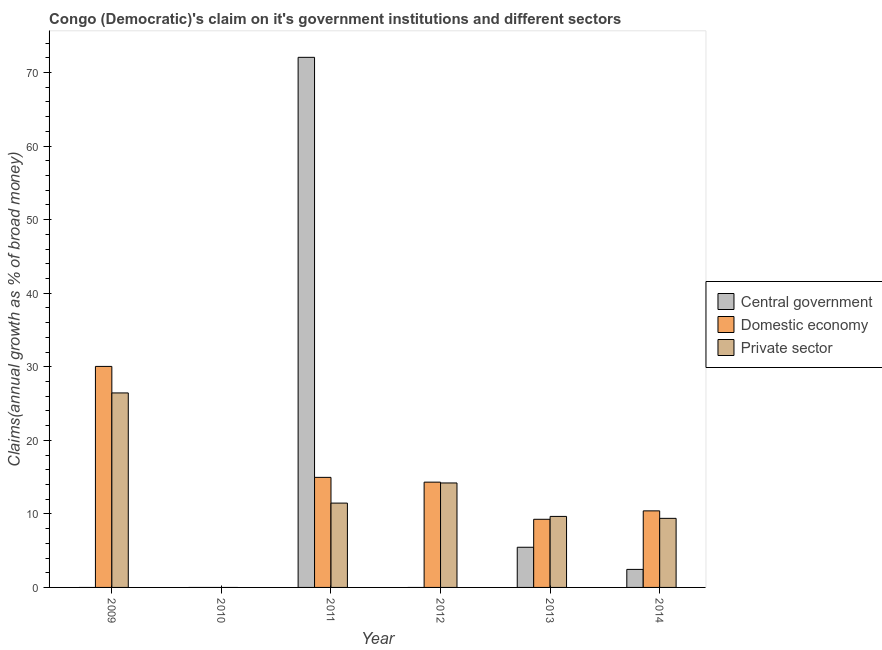How many different coloured bars are there?
Provide a succinct answer. 3. Are the number of bars per tick equal to the number of legend labels?
Offer a very short reply. No. How many bars are there on the 6th tick from the right?
Provide a succinct answer. 2. In how many cases, is the number of bars for a given year not equal to the number of legend labels?
Your response must be concise. 3. What is the percentage of claim on the private sector in 2013?
Ensure brevity in your answer.  9.65. Across all years, what is the maximum percentage of claim on the private sector?
Your response must be concise. 26.44. What is the total percentage of claim on the private sector in the graph?
Offer a very short reply. 71.15. What is the difference between the percentage of claim on the domestic economy in 2013 and that in 2014?
Ensure brevity in your answer.  -1.14. What is the difference between the percentage of claim on the private sector in 2014 and the percentage of claim on the domestic economy in 2012?
Provide a succinct answer. -4.81. What is the average percentage of claim on the domestic economy per year?
Provide a short and direct response. 13.17. In the year 2014, what is the difference between the percentage of claim on the central government and percentage of claim on the domestic economy?
Provide a succinct answer. 0. What is the ratio of the percentage of claim on the domestic economy in 2009 to that in 2012?
Ensure brevity in your answer.  2.1. What is the difference between the highest and the second highest percentage of claim on the domestic economy?
Keep it short and to the point. 15.08. What is the difference between the highest and the lowest percentage of claim on the domestic economy?
Your response must be concise. 30.05. In how many years, is the percentage of claim on the domestic economy greater than the average percentage of claim on the domestic economy taken over all years?
Your response must be concise. 3. Is it the case that in every year, the sum of the percentage of claim on the central government and percentage of claim on the domestic economy is greater than the percentage of claim on the private sector?
Give a very brief answer. No. How many bars are there?
Your response must be concise. 13. Are all the bars in the graph horizontal?
Ensure brevity in your answer.  No. How many years are there in the graph?
Provide a succinct answer. 6. What is the difference between two consecutive major ticks on the Y-axis?
Ensure brevity in your answer.  10. Are the values on the major ticks of Y-axis written in scientific E-notation?
Offer a very short reply. No. Does the graph contain grids?
Ensure brevity in your answer.  No. Where does the legend appear in the graph?
Your answer should be compact. Center right. How many legend labels are there?
Ensure brevity in your answer.  3. How are the legend labels stacked?
Your answer should be very brief. Vertical. What is the title of the graph?
Provide a short and direct response. Congo (Democratic)'s claim on it's government institutions and different sectors. Does "Ages 0-14" appear as one of the legend labels in the graph?
Ensure brevity in your answer.  No. What is the label or title of the X-axis?
Your response must be concise. Year. What is the label or title of the Y-axis?
Offer a very short reply. Claims(annual growth as % of broad money). What is the Claims(annual growth as % of broad money) in Domestic economy in 2009?
Provide a succinct answer. 30.05. What is the Claims(annual growth as % of broad money) of Private sector in 2009?
Your answer should be very brief. 26.44. What is the Claims(annual growth as % of broad money) of Private sector in 2010?
Offer a very short reply. 0. What is the Claims(annual growth as % of broad money) in Central government in 2011?
Offer a very short reply. 72.07. What is the Claims(annual growth as % of broad money) in Domestic economy in 2011?
Your answer should be compact. 14.96. What is the Claims(annual growth as % of broad money) of Private sector in 2011?
Keep it short and to the point. 11.46. What is the Claims(annual growth as % of broad money) of Central government in 2012?
Your answer should be compact. 0. What is the Claims(annual growth as % of broad money) of Domestic economy in 2012?
Your answer should be very brief. 14.31. What is the Claims(annual growth as % of broad money) in Private sector in 2012?
Provide a succinct answer. 14.2. What is the Claims(annual growth as % of broad money) in Central government in 2013?
Give a very brief answer. 5.46. What is the Claims(annual growth as % of broad money) of Domestic economy in 2013?
Offer a terse response. 9.26. What is the Claims(annual growth as % of broad money) of Private sector in 2013?
Make the answer very short. 9.65. What is the Claims(annual growth as % of broad money) in Central government in 2014?
Ensure brevity in your answer.  2.45. What is the Claims(annual growth as % of broad money) of Domestic economy in 2014?
Your response must be concise. 10.41. What is the Claims(annual growth as % of broad money) in Private sector in 2014?
Keep it short and to the point. 9.39. Across all years, what is the maximum Claims(annual growth as % of broad money) of Central government?
Make the answer very short. 72.07. Across all years, what is the maximum Claims(annual growth as % of broad money) of Domestic economy?
Give a very brief answer. 30.05. Across all years, what is the maximum Claims(annual growth as % of broad money) of Private sector?
Your answer should be compact. 26.44. Across all years, what is the minimum Claims(annual growth as % of broad money) in Central government?
Ensure brevity in your answer.  0. Across all years, what is the minimum Claims(annual growth as % of broad money) of Domestic economy?
Your answer should be compact. 0. Across all years, what is the minimum Claims(annual growth as % of broad money) of Private sector?
Provide a short and direct response. 0. What is the total Claims(annual growth as % of broad money) in Central government in the graph?
Provide a short and direct response. 79.98. What is the total Claims(annual growth as % of broad money) of Domestic economy in the graph?
Make the answer very short. 79. What is the total Claims(annual growth as % of broad money) in Private sector in the graph?
Your answer should be very brief. 71.15. What is the difference between the Claims(annual growth as % of broad money) in Domestic economy in 2009 and that in 2011?
Make the answer very short. 15.08. What is the difference between the Claims(annual growth as % of broad money) in Private sector in 2009 and that in 2011?
Offer a very short reply. 14.98. What is the difference between the Claims(annual growth as % of broad money) of Domestic economy in 2009 and that in 2012?
Make the answer very short. 15.73. What is the difference between the Claims(annual growth as % of broad money) in Private sector in 2009 and that in 2012?
Offer a terse response. 12.24. What is the difference between the Claims(annual growth as % of broad money) of Domestic economy in 2009 and that in 2013?
Provide a short and direct response. 20.78. What is the difference between the Claims(annual growth as % of broad money) in Private sector in 2009 and that in 2013?
Give a very brief answer. 16.79. What is the difference between the Claims(annual growth as % of broad money) of Domestic economy in 2009 and that in 2014?
Make the answer very short. 19.64. What is the difference between the Claims(annual growth as % of broad money) in Private sector in 2009 and that in 2014?
Keep it short and to the point. 17.05. What is the difference between the Claims(annual growth as % of broad money) in Domestic economy in 2011 and that in 2012?
Give a very brief answer. 0.65. What is the difference between the Claims(annual growth as % of broad money) of Private sector in 2011 and that in 2012?
Offer a very short reply. -2.74. What is the difference between the Claims(annual growth as % of broad money) of Central government in 2011 and that in 2013?
Offer a terse response. 66.61. What is the difference between the Claims(annual growth as % of broad money) in Domestic economy in 2011 and that in 2013?
Your answer should be very brief. 5.7. What is the difference between the Claims(annual growth as % of broad money) in Private sector in 2011 and that in 2013?
Keep it short and to the point. 1.81. What is the difference between the Claims(annual growth as % of broad money) of Central government in 2011 and that in 2014?
Your answer should be very brief. 69.62. What is the difference between the Claims(annual growth as % of broad money) of Domestic economy in 2011 and that in 2014?
Your answer should be compact. 4.56. What is the difference between the Claims(annual growth as % of broad money) of Private sector in 2011 and that in 2014?
Your answer should be very brief. 2.07. What is the difference between the Claims(annual growth as % of broad money) in Domestic economy in 2012 and that in 2013?
Your answer should be compact. 5.05. What is the difference between the Claims(annual growth as % of broad money) in Private sector in 2012 and that in 2013?
Your answer should be compact. 4.55. What is the difference between the Claims(annual growth as % of broad money) in Domestic economy in 2012 and that in 2014?
Your response must be concise. 3.91. What is the difference between the Claims(annual growth as % of broad money) in Private sector in 2012 and that in 2014?
Your answer should be compact. 4.81. What is the difference between the Claims(annual growth as % of broad money) in Central government in 2013 and that in 2014?
Your response must be concise. 3.01. What is the difference between the Claims(annual growth as % of broad money) in Domestic economy in 2013 and that in 2014?
Your response must be concise. -1.14. What is the difference between the Claims(annual growth as % of broad money) in Private sector in 2013 and that in 2014?
Ensure brevity in your answer.  0.26. What is the difference between the Claims(annual growth as % of broad money) of Domestic economy in 2009 and the Claims(annual growth as % of broad money) of Private sector in 2011?
Give a very brief answer. 18.58. What is the difference between the Claims(annual growth as % of broad money) of Domestic economy in 2009 and the Claims(annual growth as % of broad money) of Private sector in 2012?
Provide a short and direct response. 15.85. What is the difference between the Claims(annual growth as % of broad money) in Domestic economy in 2009 and the Claims(annual growth as % of broad money) in Private sector in 2013?
Provide a short and direct response. 20.39. What is the difference between the Claims(annual growth as % of broad money) in Domestic economy in 2009 and the Claims(annual growth as % of broad money) in Private sector in 2014?
Your response must be concise. 20.66. What is the difference between the Claims(annual growth as % of broad money) of Central government in 2011 and the Claims(annual growth as % of broad money) of Domestic economy in 2012?
Ensure brevity in your answer.  57.76. What is the difference between the Claims(annual growth as % of broad money) of Central government in 2011 and the Claims(annual growth as % of broad money) of Private sector in 2012?
Provide a short and direct response. 57.87. What is the difference between the Claims(annual growth as % of broad money) of Domestic economy in 2011 and the Claims(annual growth as % of broad money) of Private sector in 2012?
Your response must be concise. 0.76. What is the difference between the Claims(annual growth as % of broad money) in Central government in 2011 and the Claims(annual growth as % of broad money) in Domestic economy in 2013?
Provide a succinct answer. 62.81. What is the difference between the Claims(annual growth as % of broad money) in Central government in 2011 and the Claims(annual growth as % of broad money) in Private sector in 2013?
Your response must be concise. 62.41. What is the difference between the Claims(annual growth as % of broad money) of Domestic economy in 2011 and the Claims(annual growth as % of broad money) of Private sector in 2013?
Provide a short and direct response. 5.31. What is the difference between the Claims(annual growth as % of broad money) of Central government in 2011 and the Claims(annual growth as % of broad money) of Domestic economy in 2014?
Keep it short and to the point. 61.66. What is the difference between the Claims(annual growth as % of broad money) in Central government in 2011 and the Claims(annual growth as % of broad money) in Private sector in 2014?
Make the answer very short. 62.68. What is the difference between the Claims(annual growth as % of broad money) in Domestic economy in 2011 and the Claims(annual growth as % of broad money) in Private sector in 2014?
Your answer should be very brief. 5.57. What is the difference between the Claims(annual growth as % of broad money) in Domestic economy in 2012 and the Claims(annual growth as % of broad money) in Private sector in 2013?
Offer a terse response. 4.66. What is the difference between the Claims(annual growth as % of broad money) of Domestic economy in 2012 and the Claims(annual growth as % of broad money) of Private sector in 2014?
Provide a succinct answer. 4.92. What is the difference between the Claims(annual growth as % of broad money) in Central government in 2013 and the Claims(annual growth as % of broad money) in Domestic economy in 2014?
Your answer should be very brief. -4.95. What is the difference between the Claims(annual growth as % of broad money) in Central government in 2013 and the Claims(annual growth as % of broad money) in Private sector in 2014?
Offer a terse response. -3.93. What is the difference between the Claims(annual growth as % of broad money) in Domestic economy in 2013 and the Claims(annual growth as % of broad money) in Private sector in 2014?
Your answer should be compact. -0.13. What is the average Claims(annual growth as % of broad money) in Central government per year?
Offer a terse response. 13.33. What is the average Claims(annual growth as % of broad money) in Domestic economy per year?
Your answer should be very brief. 13.17. What is the average Claims(annual growth as % of broad money) in Private sector per year?
Your response must be concise. 11.86. In the year 2009, what is the difference between the Claims(annual growth as % of broad money) of Domestic economy and Claims(annual growth as % of broad money) of Private sector?
Give a very brief answer. 3.61. In the year 2011, what is the difference between the Claims(annual growth as % of broad money) in Central government and Claims(annual growth as % of broad money) in Domestic economy?
Give a very brief answer. 57.11. In the year 2011, what is the difference between the Claims(annual growth as % of broad money) of Central government and Claims(annual growth as % of broad money) of Private sector?
Keep it short and to the point. 60.6. In the year 2011, what is the difference between the Claims(annual growth as % of broad money) in Domestic economy and Claims(annual growth as % of broad money) in Private sector?
Make the answer very short. 3.5. In the year 2012, what is the difference between the Claims(annual growth as % of broad money) in Domestic economy and Claims(annual growth as % of broad money) in Private sector?
Provide a short and direct response. 0.11. In the year 2013, what is the difference between the Claims(annual growth as % of broad money) in Central government and Claims(annual growth as % of broad money) in Domestic economy?
Provide a short and direct response. -3.8. In the year 2013, what is the difference between the Claims(annual growth as % of broad money) in Central government and Claims(annual growth as % of broad money) in Private sector?
Your answer should be compact. -4.19. In the year 2013, what is the difference between the Claims(annual growth as % of broad money) in Domestic economy and Claims(annual growth as % of broad money) in Private sector?
Your answer should be very brief. -0.39. In the year 2014, what is the difference between the Claims(annual growth as % of broad money) in Central government and Claims(annual growth as % of broad money) in Domestic economy?
Give a very brief answer. -7.96. In the year 2014, what is the difference between the Claims(annual growth as % of broad money) of Central government and Claims(annual growth as % of broad money) of Private sector?
Your answer should be compact. -6.94. In the year 2014, what is the difference between the Claims(annual growth as % of broad money) of Domestic economy and Claims(annual growth as % of broad money) of Private sector?
Offer a terse response. 1.02. What is the ratio of the Claims(annual growth as % of broad money) in Domestic economy in 2009 to that in 2011?
Your answer should be compact. 2.01. What is the ratio of the Claims(annual growth as % of broad money) of Private sector in 2009 to that in 2011?
Make the answer very short. 2.31. What is the ratio of the Claims(annual growth as % of broad money) in Domestic economy in 2009 to that in 2012?
Your response must be concise. 2.1. What is the ratio of the Claims(annual growth as % of broad money) in Private sector in 2009 to that in 2012?
Your answer should be compact. 1.86. What is the ratio of the Claims(annual growth as % of broad money) in Domestic economy in 2009 to that in 2013?
Your response must be concise. 3.24. What is the ratio of the Claims(annual growth as % of broad money) of Private sector in 2009 to that in 2013?
Make the answer very short. 2.74. What is the ratio of the Claims(annual growth as % of broad money) of Domestic economy in 2009 to that in 2014?
Keep it short and to the point. 2.89. What is the ratio of the Claims(annual growth as % of broad money) in Private sector in 2009 to that in 2014?
Make the answer very short. 2.82. What is the ratio of the Claims(annual growth as % of broad money) of Domestic economy in 2011 to that in 2012?
Make the answer very short. 1.05. What is the ratio of the Claims(annual growth as % of broad money) of Private sector in 2011 to that in 2012?
Your answer should be compact. 0.81. What is the ratio of the Claims(annual growth as % of broad money) of Central government in 2011 to that in 2013?
Your answer should be very brief. 13.2. What is the ratio of the Claims(annual growth as % of broad money) in Domestic economy in 2011 to that in 2013?
Ensure brevity in your answer.  1.62. What is the ratio of the Claims(annual growth as % of broad money) of Private sector in 2011 to that in 2013?
Your answer should be very brief. 1.19. What is the ratio of the Claims(annual growth as % of broad money) of Central government in 2011 to that in 2014?
Ensure brevity in your answer.  29.4. What is the ratio of the Claims(annual growth as % of broad money) in Domestic economy in 2011 to that in 2014?
Keep it short and to the point. 1.44. What is the ratio of the Claims(annual growth as % of broad money) of Private sector in 2011 to that in 2014?
Give a very brief answer. 1.22. What is the ratio of the Claims(annual growth as % of broad money) in Domestic economy in 2012 to that in 2013?
Keep it short and to the point. 1.55. What is the ratio of the Claims(annual growth as % of broad money) of Private sector in 2012 to that in 2013?
Give a very brief answer. 1.47. What is the ratio of the Claims(annual growth as % of broad money) in Domestic economy in 2012 to that in 2014?
Give a very brief answer. 1.38. What is the ratio of the Claims(annual growth as % of broad money) of Private sector in 2012 to that in 2014?
Ensure brevity in your answer.  1.51. What is the ratio of the Claims(annual growth as % of broad money) of Central government in 2013 to that in 2014?
Your answer should be compact. 2.23. What is the ratio of the Claims(annual growth as % of broad money) in Domestic economy in 2013 to that in 2014?
Ensure brevity in your answer.  0.89. What is the ratio of the Claims(annual growth as % of broad money) of Private sector in 2013 to that in 2014?
Your response must be concise. 1.03. What is the difference between the highest and the second highest Claims(annual growth as % of broad money) of Central government?
Offer a terse response. 66.61. What is the difference between the highest and the second highest Claims(annual growth as % of broad money) in Domestic economy?
Provide a short and direct response. 15.08. What is the difference between the highest and the second highest Claims(annual growth as % of broad money) in Private sector?
Offer a terse response. 12.24. What is the difference between the highest and the lowest Claims(annual growth as % of broad money) of Central government?
Ensure brevity in your answer.  72.07. What is the difference between the highest and the lowest Claims(annual growth as % of broad money) in Domestic economy?
Offer a terse response. 30.05. What is the difference between the highest and the lowest Claims(annual growth as % of broad money) of Private sector?
Your answer should be very brief. 26.44. 